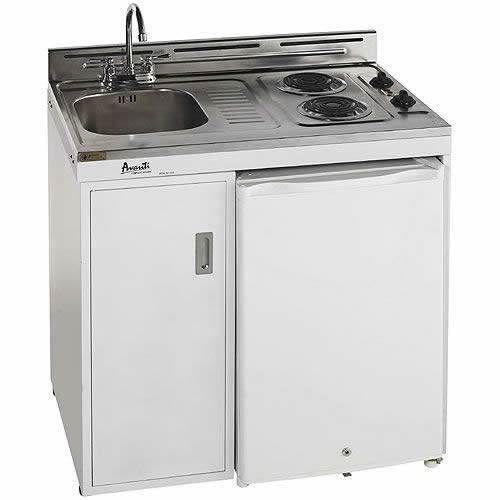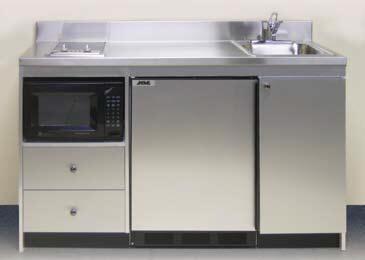The first image is the image on the left, the second image is the image on the right. Examine the images to the left and right. Is the description "One refrigerator door is all the way wide open and the door shelves are showing." accurate? Answer yes or no. No. The first image is the image on the left, the second image is the image on the right. For the images displayed, is the sentence "Only one refrigerator has its door open, and it has no contents within." factually correct? Answer yes or no. No. 